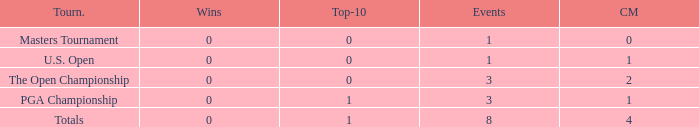For events with values of exactly 1, and 0 cuts made, what is the fewest number of top-10s? 0.0. 